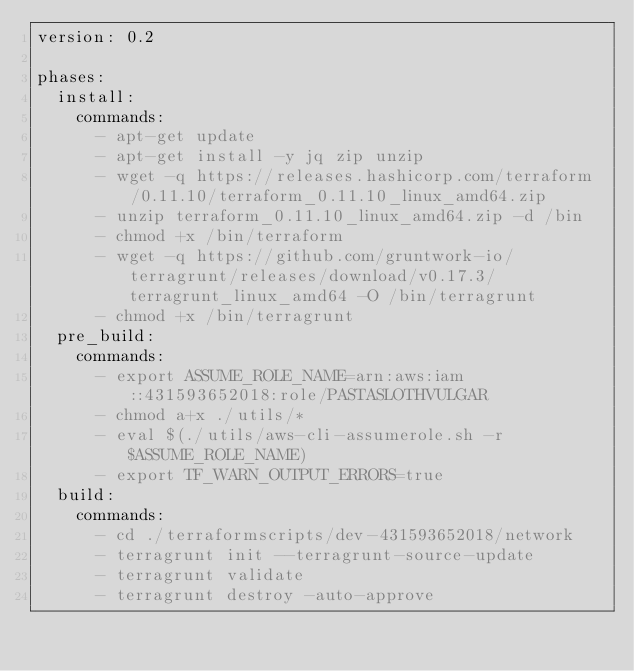<code> <loc_0><loc_0><loc_500><loc_500><_YAML_>version: 0.2

phases:
  install:
    commands:
      - apt-get update
      - apt-get install -y jq zip unzip
      - wget -q https://releases.hashicorp.com/terraform/0.11.10/terraform_0.11.10_linux_amd64.zip
      - unzip terraform_0.11.10_linux_amd64.zip -d /bin
      - chmod +x /bin/terraform
      - wget -q https://github.com/gruntwork-io/terragrunt/releases/download/v0.17.3/terragrunt_linux_amd64 -O /bin/terragrunt
      - chmod +x /bin/terragrunt
  pre_build:
    commands:
      - export ASSUME_ROLE_NAME=arn:aws:iam::431593652018:role/PASTASLOTHVULGAR
      - chmod a+x ./utils/*
      - eval $(./utils/aws-cli-assumerole.sh -r $ASSUME_ROLE_NAME)
      - export TF_WARN_OUTPUT_ERRORS=true
  build:
    commands:
      - cd ./terraformscripts/dev-431593652018/network 
      - terragrunt init --terragrunt-source-update
      - terragrunt validate
      - terragrunt destroy -auto-approve
</code> 